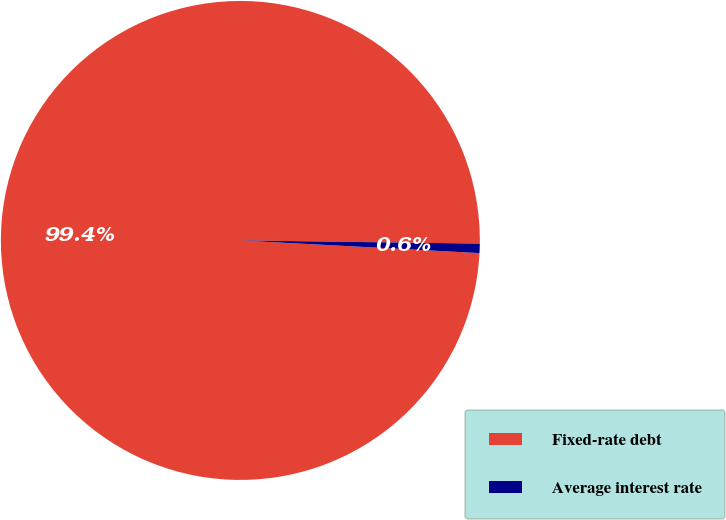<chart> <loc_0><loc_0><loc_500><loc_500><pie_chart><fcel>Fixed-rate debt<fcel>Average interest rate<nl><fcel>99.37%<fcel>0.63%<nl></chart> 